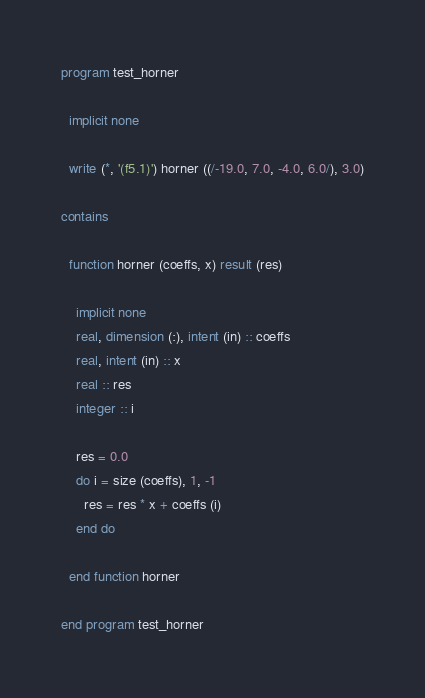<code> <loc_0><loc_0><loc_500><loc_500><_FORTRAN_>program test_horner

  implicit none

  write (*, '(f5.1)') horner ((/-19.0, 7.0, -4.0, 6.0/), 3.0)

contains

  function horner (coeffs, x) result (res)

    implicit none
    real, dimension (:), intent (in) :: coeffs
    real, intent (in) :: x
    real :: res
    integer :: i

    res = 0.0
    do i = size (coeffs), 1, -1
      res = res * x + coeffs (i)
    end do

  end function horner

end program test_horner
</code> 